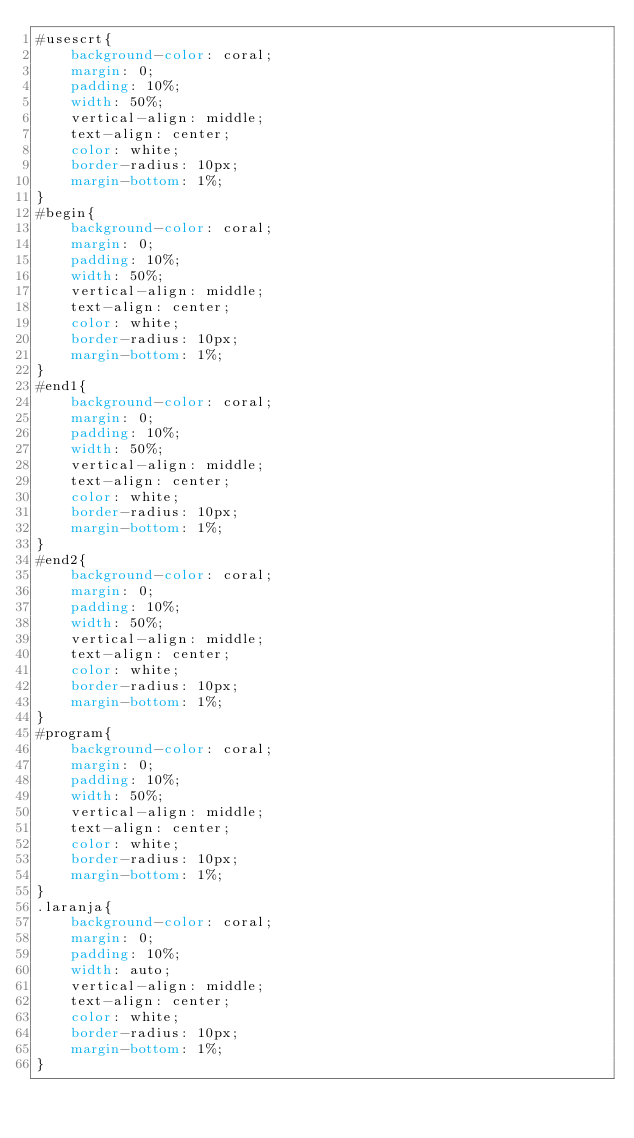<code> <loc_0><loc_0><loc_500><loc_500><_CSS_>#usescrt{
    background-color: coral;
    margin: 0;
    padding: 10%;
    width: 50%;
    vertical-align: middle;
    text-align: center;
    color: white;
    border-radius: 10px;
    margin-bottom: 1%;
}
#begin{
    background-color: coral;
    margin: 0;
    padding: 10%;
    width: 50%;
    vertical-align: middle;
    text-align: center;
    color: white;
    border-radius: 10px;
    margin-bottom: 1%;
}
#end1{
    background-color: coral;
    margin: 0;
    padding: 10%;
    width: 50%;
    vertical-align: middle;
    text-align: center;
    color: white;
    border-radius: 10px;
    margin-bottom: 1%;
}
#end2{
    background-color: coral;
    margin: 0;
    padding: 10%;
    width: 50%;
    vertical-align: middle;
    text-align: center;
    color: white;
    border-radius: 10px;
    margin-bottom: 1%;
}
#program{
    background-color: coral;
    margin: 0;
    padding: 10%;
    width: 50%;
    vertical-align: middle;
    text-align: center;
    color: white;
    border-radius: 10px;
    margin-bottom: 1%;
}
.laranja{
    background-color: coral;
    margin: 0;
    padding: 10%;
    width: auto;
    vertical-align: middle;
    text-align: center;
    color: white;
    border-radius: 10px;
    margin-bottom: 1%;
}</code> 